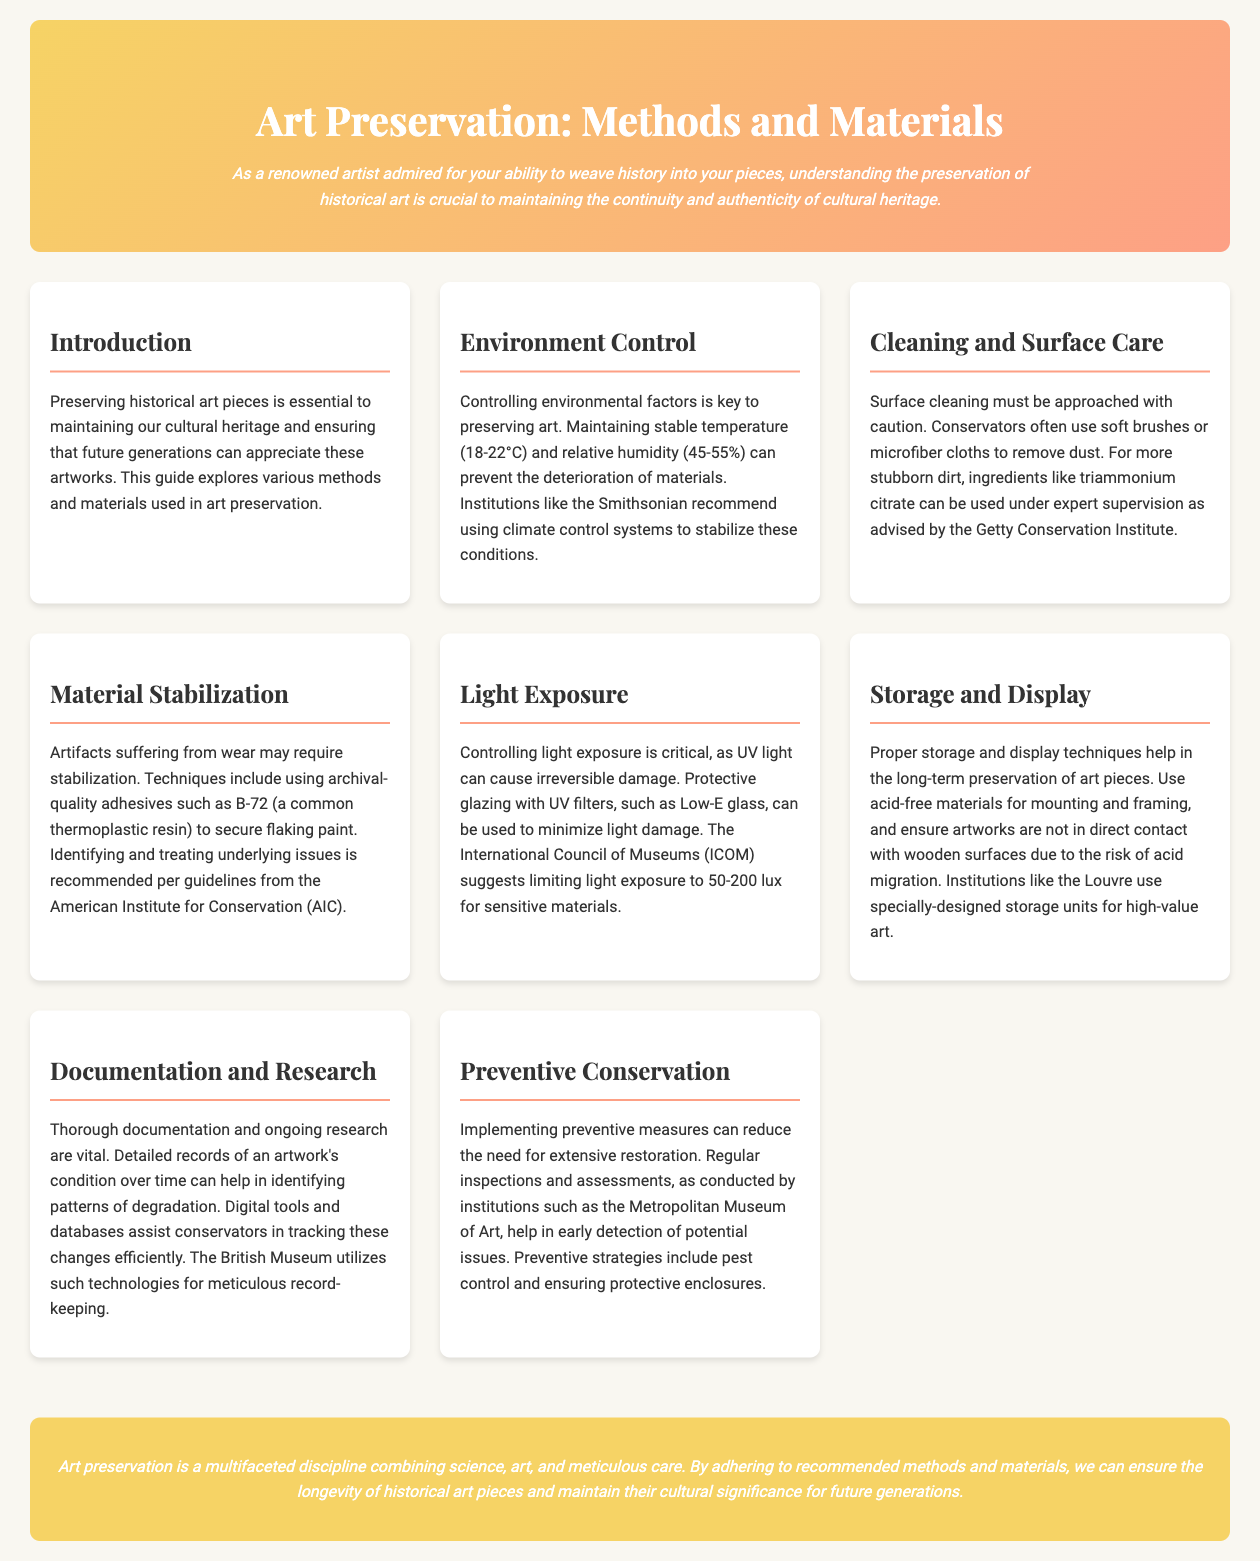What is the ideal temperature for art preservation? The document states that maintaining a stable temperature is key to art preservation, which should be between 18-22°C.
Answer: 18-22°C What material is commonly used for surface cleaning? The guide mentions that conservators often use soft brushes or microfiber cloths for dust removal.
Answer: Soft brushes or microfiber cloths What is a recommended adhesive for material stabilization? The document suggests using archival-quality adhesives such as B-72 for securing flaking paint.
Answer: B-72 What is the suggested light exposure limit for sensitive materials? According to the International Council of Museums (ICOM), the light exposure should be limited to 50-200 lux for sensitive materials.
Answer: 50-200 lux What technique can reduce the need for extensive restoration? The text discusses that implementing preventive measures through regular inspections and assessments can minimize the need for extensive restoration.
Answer: Preventive measures How does light exposure affect historical art? The document explains that UV light exposure can cause irreversible damage to artworks.
Answer: Irreversible damage What type of materials should be used for mounting and framing? The guide recommends using acid-free materials for mounting and framing artworks.
Answer: Acid-free materials Which institution uses digital tools and databases for record-keeping? The British Museum is mentioned as utilizing technologies for meticulous record-keeping.
Answer: British Museum What does preventive conservation help with? The document states that preventive conservation helps in early detection of potential issues in artworks.
Answer: Early detection of potential issues 